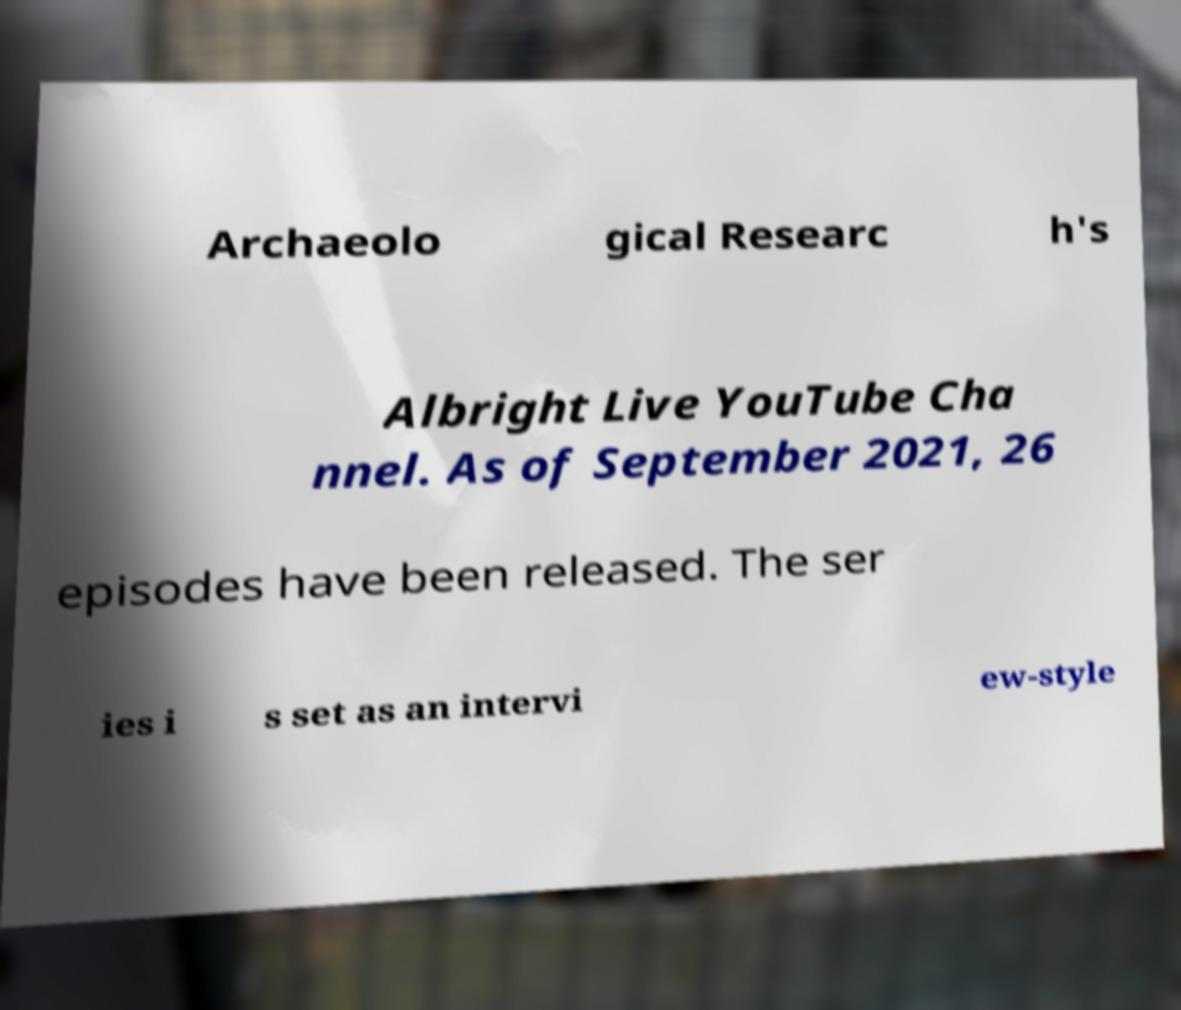Can you accurately transcribe the text from the provided image for me? Archaeolo gical Researc h's Albright Live YouTube Cha nnel. As of September 2021, 26 episodes have been released. The ser ies i s set as an intervi ew-style 